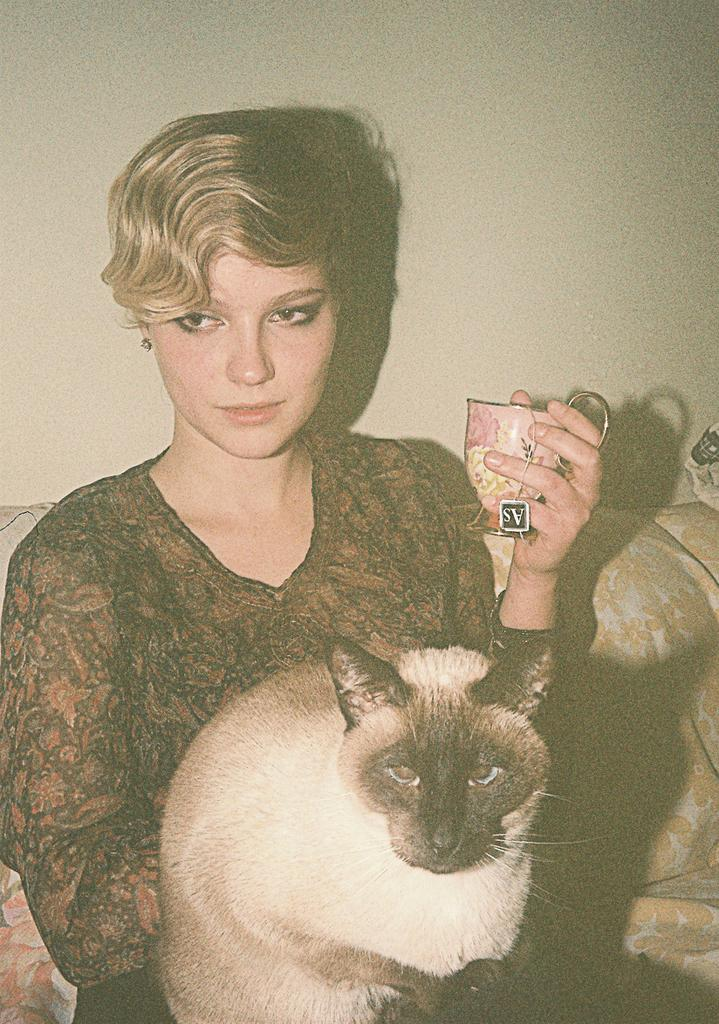Who is the main subject in the image? There is a woman in the image. What is the woman holding in the image? The woman is holding a cat and a cup. What is the woman sitting on in the image? The woman is seated on a sofa. What type of whip is the woman using to start the race in the image? There is no whip or race present in the image; the woman is holding a cat and a cup while seated on a sofa. 